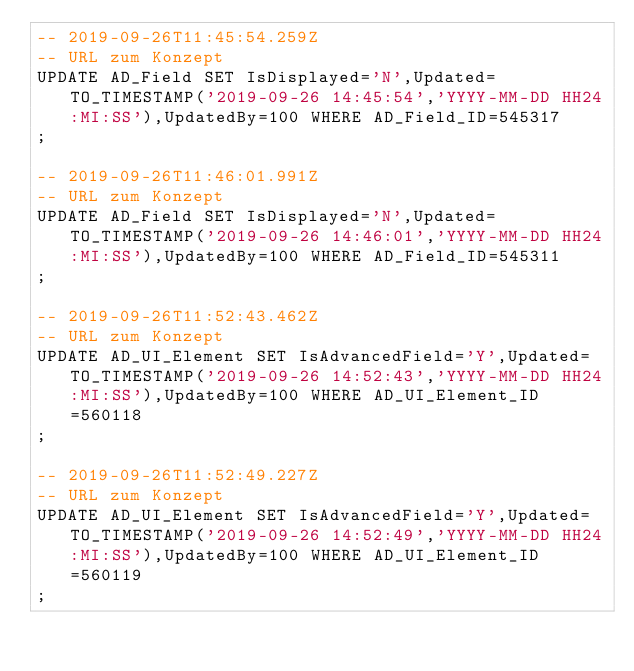Convert code to text. <code><loc_0><loc_0><loc_500><loc_500><_SQL_>-- 2019-09-26T11:45:54.259Z
-- URL zum Konzept
UPDATE AD_Field SET IsDisplayed='N',Updated=TO_TIMESTAMP('2019-09-26 14:45:54','YYYY-MM-DD HH24:MI:SS'),UpdatedBy=100 WHERE AD_Field_ID=545317
;

-- 2019-09-26T11:46:01.991Z
-- URL zum Konzept
UPDATE AD_Field SET IsDisplayed='N',Updated=TO_TIMESTAMP('2019-09-26 14:46:01','YYYY-MM-DD HH24:MI:SS'),UpdatedBy=100 WHERE AD_Field_ID=545311
;

-- 2019-09-26T11:52:43.462Z
-- URL zum Konzept
UPDATE AD_UI_Element SET IsAdvancedField='Y',Updated=TO_TIMESTAMP('2019-09-26 14:52:43','YYYY-MM-DD HH24:MI:SS'),UpdatedBy=100 WHERE AD_UI_Element_ID=560118
;

-- 2019-09-26T11:52:49.227Z
-- URL zum Konzept
UPDATE AD_UI_Element SET IsAdvancedField='Y',Updated=TO_TIMESTAMP('2019-09-26 14:52:49','YYYY-MM-DD HH24:MI:SS'),UpdatedBy=100 WHERE AD_UI_Element_ID=560119
;

</code> 